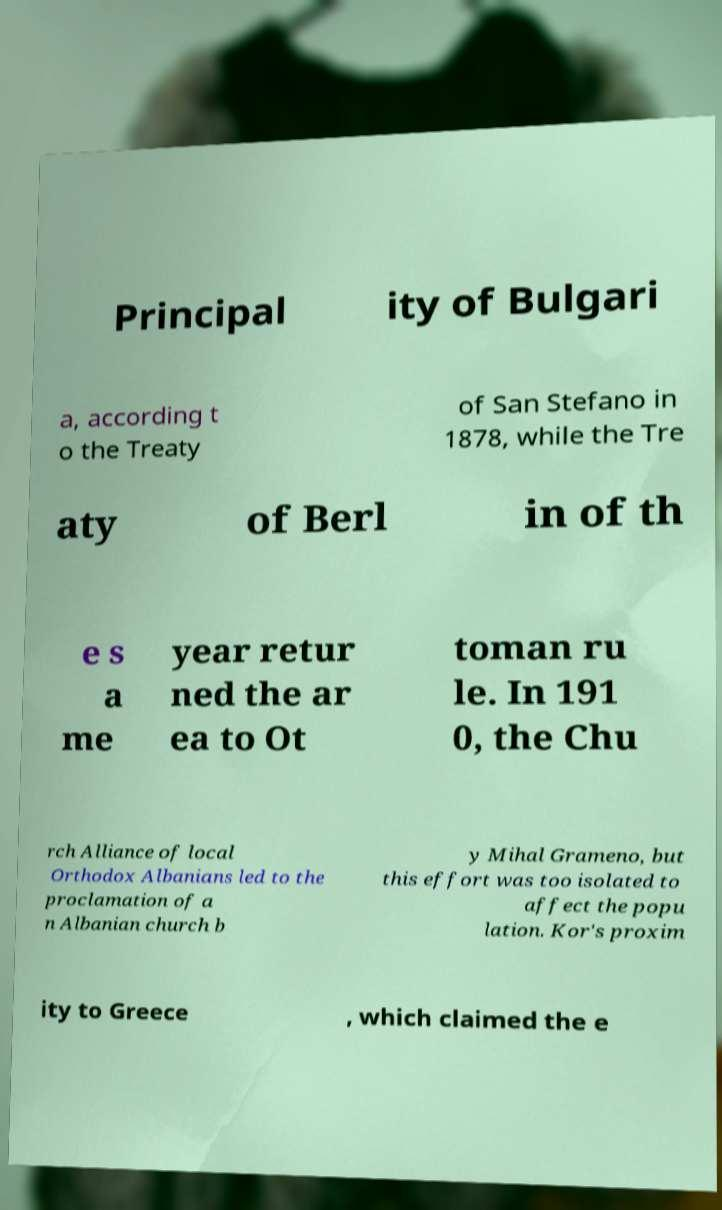Could you extract and type out the text from this image? Principal ity of Bulgari a, according t o the Treaty of San Stefano in 1878, while the Tre aty of Berl in of th e s a me year retur ned the ar ea to Ot toman ru le. In 191 0, the Chu rch Alliance of local Orthodox Albanians led to the proclamation of a n Albanian church b y Mihal Grameno, but this effort was too isolated to affect the popu lation. Kor's proxim ity to Greece , which claimed the e 